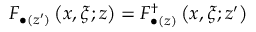Convert formula to latex. <formula><loc_0><loc_0><loc_500><loc_500>F _ { \bullet ( z ^ { \prime } ) } \left ( x , \xi ; z \right ) = F _ { \bullet ( z ) } ^ { \dagger } \left ( x , \xi ; z ^ { \prime } \right )</formula> 